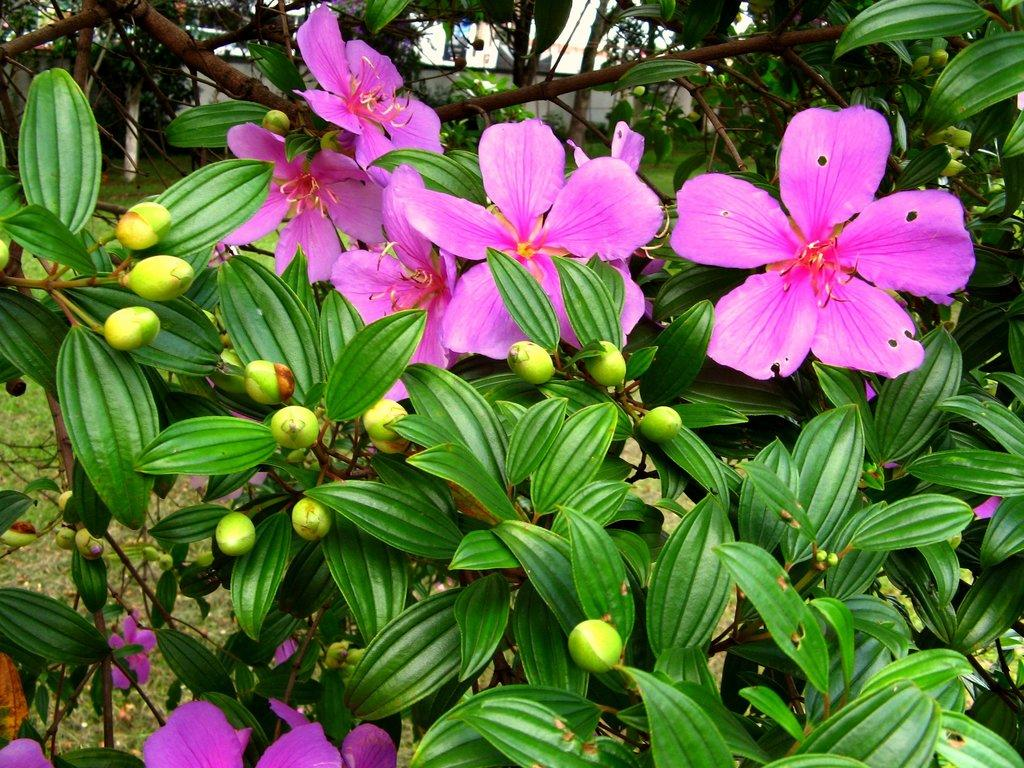What type of flowers can be seen in the image? There are pink flowers in the image. What stage of growth are some of the flowers in? There are buds in the image. What color are the leaves in the image? There are green leaves in the image. What unit of measurement is used to determine the age of the flowers in the image? There is no unit of measurement mentioned in the image, and the age of the flowers cannot be determined from the provided facts. 